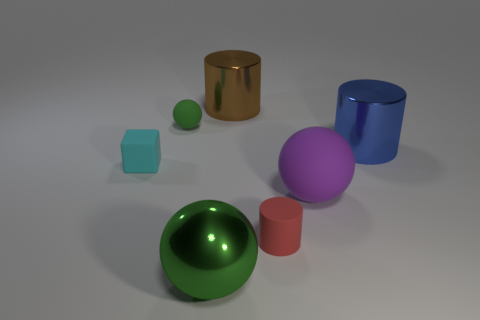Are there the same number of big green spheres on the left side of the large green metal sphere and cyan blocks?
Provide a short and direct response. No. What number of tiny red matte cylinders are behind the red rubber cylinder?
Your answer should be very brief. 0. What size is the red matte object?
Provide a succinct answer. Small. The big object that is made of the same material as the block is what color?
Give a very brief answer. Purple. What number of brown cylinders are the same size as the red object?
Keep it short and to the point. 0. Do the tiny thing that is to the left of the small sphere and the brown cylinder have the same material?
Offer a terse response. No. Is the number of cyan blocks left of the large brown metallic cylinder less than the number of cylinders?
Offer a terse response. Yes. What shape is the object that is to the right of the purple sphere?
Provide a succinct answer. Cylinder. The blue metallic thing that is the same size as the green metallic ball is what shape?
Make the answer very short. Cylinder. Are there any blue things that have the same shape as the big purple matte object?
Ensure brevity in your answer.  No. 